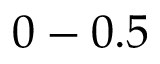Convert formula to latex. <formula><loc_0><loc_0><loc_500><loc_500>0 - 0 . 5</formula> 